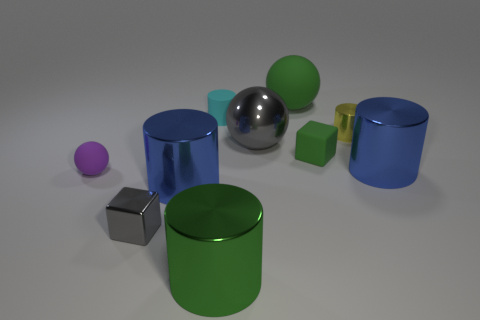Which objects are closest to the large transparent sphere? The objects closest to the large transparent sphere are the small lime green cube and the royal blue cylinder. 